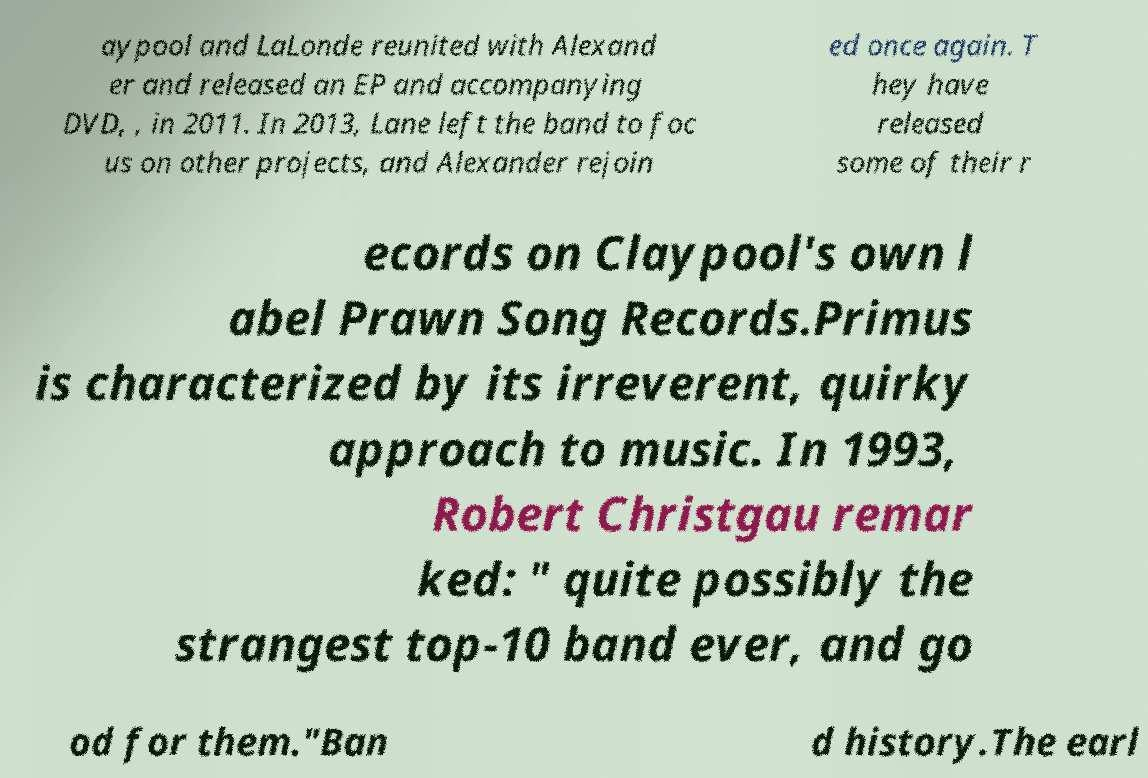Can you read and provide the text displayed in the image?This photo seems to have some interesting text. Can you extract and type it out for me? aypool and LaLonde reunited with Alexand er and released an EP and accompanying DVD, , in 2011. In 2013, Lane left the band to foc us on other projects, and Alexander rejoin ed once again. T hey have released some of their r ecords on Claypool's own l abel Prawn Song Records.Primus is characterized by its irreverent, quirky approach to music. In 1993, Robert Christgau remar ked: " quite possibly the strangest top-10 band ever, and go od for them."Ban d history.The earl 